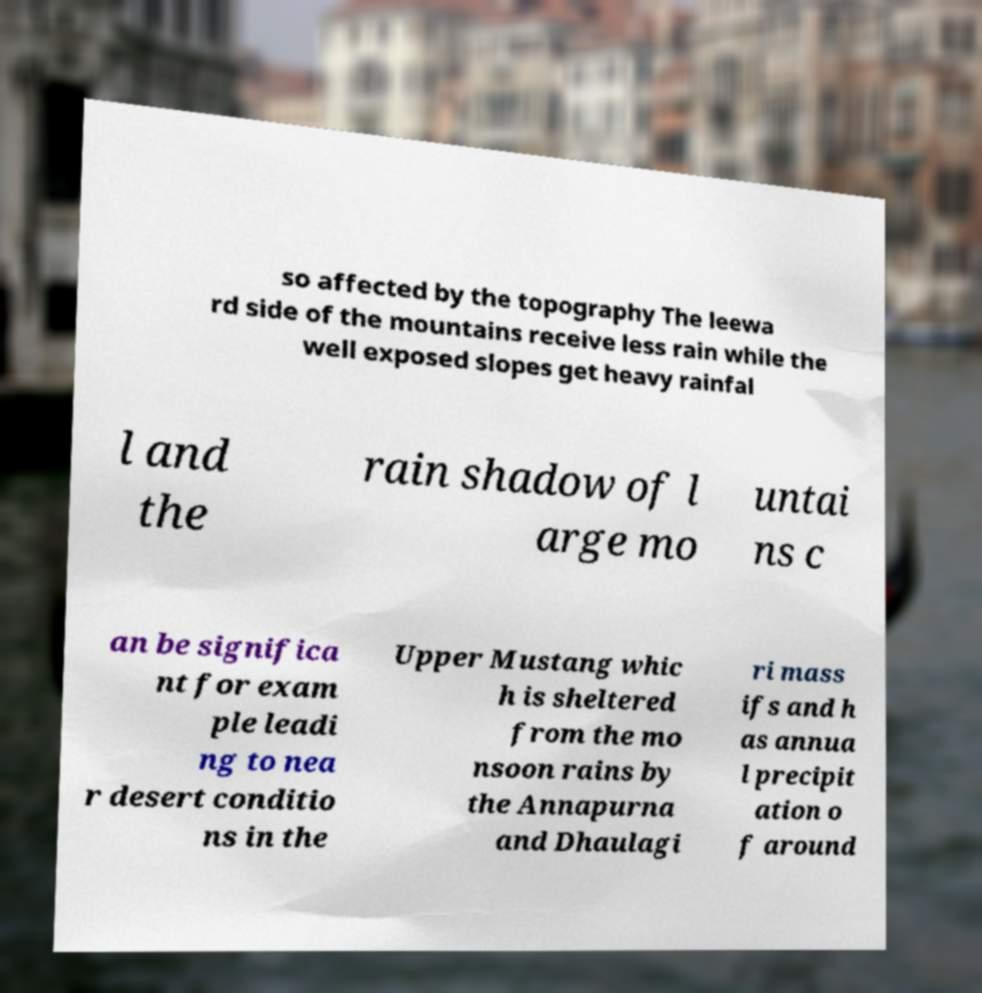There's text embedded in this image that I need extracted. Can you transcribe it verbatim? so affected by the topography The leewa rd side of the mountains receive less rain while the well exposed slopes get heavy rainfal l and the rain shadow of l arge mo untai ns c an be significa nt for exam ple leadi ng to nea r desert conditio ns in the Upper Mustang whic h is sheltered from the mo nsoon rains by the Annapurna and Dhaulagi ri mass ifs and h as annua l precipit ation o f around 